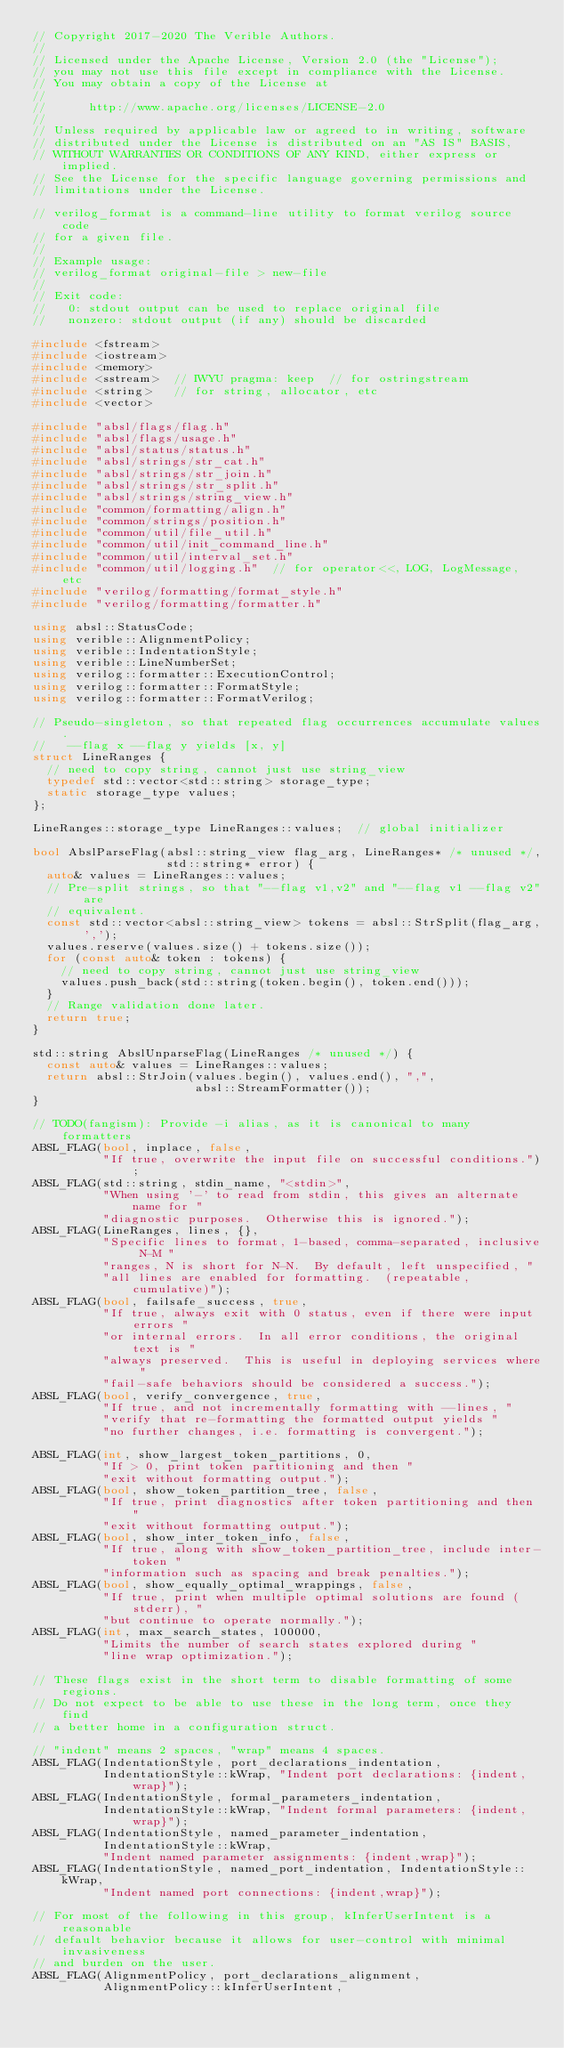Convert code to text. <code><loc_0><loc_0><loc_500><loc_500><_C++_>// Copyright 2017-2020 The Verible Authors.
//
// Licensed under the Apache License, Version 2.0 (the "License");
// you may not use this file except in compliance with the License.
// You may obtain a copy of the License at
//
//      http://www.apache.org/licenses/LICENSE-2.0
//
// Unless required by applicable law or agreed to in writing, software
// distributed under the License is distributed on an "AS IS" BASIS,
// WITHOUT WARRANTIES OR CONDITIONS OF ANY KIND, either express or implied.
// See the License for the specific language governing permissions and
// limitations under the License.

// verilog_format is a command-line utility to format verilog source code
// for a given file.
//
// Example usage:
// verilog_format original-file > new-file
//
// Exit code:
//   0: stdout output can be used to replace original file
//   nonzero: stdout output (if any) should be discarded

#include <fstream>
#include <iostream>
#include <memory>
#include <sstream>  // IWYU pragma: keep  // for ostringstream
#include <string>   // for string, allocator, etc
#include <vector>

#include "absl/flags/flag.h"
#include "absl/flags/usage.h"
#include "absl/status/status.h"
#include "absl/strings/str_cat.h"
#include "absl/strings/str_join.h"
#include "absl/strings/str_split.h"
#include "absl/strings/string_view.h"
#include "common/formatting/align.h"
#include "common/strings/position.h"
#include "common/util/file_util.h"
#include "common/util/init_command_line.h"
#include "common/util/interval_set.h"
#include "common/util/logging.h"  // for operator<<, LOG, LogMessage, etc
#include "verilog/formatting/format_style.h"
#include "verilog/formatting/formatter.h"

using absl::StatusCode;
using verible::AlignmentPolicy;
using verible::IndentationStyle;
using verible::LineNumberSet;
using verilog::formatter::ExecutionControl;
using verilog::formatter::FormatStyle;
using verilog::formatter::FormatVerilog;

// Pseudo-singleton, so that repeated flag occurrences accumulate values.
//   --flag x --flag y yields [x, y]
struct LineRanges {
  // need to copy string, cannot just use string_view
  typedef std::vector<std::string> storage_type;
  static storage_type values;
};

LineRanges::storage_type LineRanges::values;  // global initializer

bool AbslParseFlag(absl::string_view flag_arg, LineRanges* /* unused */,
                   std::string* error) {
  auto& values = LineRanges::values;
  // Pre-split strings, so that "--flag v1,v2" and "--flag v1 --flag v2" are
  // equivalent.
  const std::vector<absl::string_view> tokens = absl::StrSplit(flag_arg, ',');
  values.reserve(values.size() + tokens.size());
  for (const auto& token : tokens) {
    // need to copy string, cannot just use string_view
    values.push_back(std::string(token.begin(), token.end()));
  }
  // Range validation done later.
  return true;
}

std::string AbslUnparseFlag(LineRanges /* unused */) {
  const auto& values = LineRanges::values;
  return absl::StrJoin(values.begin(), values.end(), ",",
                       absl::StreamFormatter());
}

// TODO(fangism): Provide -i alias, as it is canonical to many formatters
ABSL_FLAG(bool, inplace, false,
          "If true, overwrite the input file on successful conditions.");
ABSL_FLAG(std::string, stdin_name, "<stdin>",
          "When using '-' to read from stdin, this gives an alternate name for "
          "diagnostic purposes.  Otherwise this is ignored.");
ABSL_FLAG(LineRanges, lines, {},
          "Specific lines to format, 1-based, comma-separated, inclusive N-M "
          "ranges, N is short for N-N.  By default, left unspecified, "
          "all lines are enabled for formatting.  (repeatable, cumulative)");
ABSL_FLAG(bool, failsafe_success, true,
          "If true, always exit with 0 status, even if there were input errors "
          "or internal errors.  In all error conditions, the original text is "
          "always preserved.  This is useful in deploying services where "
          "fail-safe behaviors should be considered a success.");
ABSL_FLAG(bool, verify_convergence, true,
          "If true, and not incrementally formatting with --lines, "
          "verify that re-formatting the formatted output yields "
          "no further changes, i.e. formatting is convergent.");

ABSL_FLAG(int, show_largest_token_partitions, 0,
          "If > 0, print token partitioning and then "
          "exit without formatting output.");
ABSL_FLAG(bool, show_token_partition_tree, false,
          "If true, print diagnostics after token partitioning and then "
          "exit without formatting output.");
ABSL_FLAG(bool, show_inter_token_info, false,
          "If true, along with show_token_partition_tree, include inter-token "
          "information such as spacing and break penalties.");
ABSL_FLAG(bool, show_equally_optimal_wrappings, false,
          "If true, print when multiple optimal solutions are found (stderr), "
          "but continue to operate normally.");
ABSL_FLAG(int, max_search_states, 100000,
          "Limits the number of search states explored during "
          "line wrap optimization.");

// These flags exist in the short term to disable formatting of some regions.
// Do not expect to be able to use these in the long term, once they find
// a better home in a configuration struct.

// "indent" means 2 spaces, "wrap" means 4 spaces.
ABSL_FLAG(IndentationStyle, port_declarations_indentation,
          IndentationStyle::kWrap, "Indent port declarations: {indent,wrap}");
ABSL_FLAG(IndentationStyle, formal_parameters_indentation,
          IndentationStyle::kWrap, "Indent formal parameters: {indent,wrap}");
ABSL_FLAG(IndentationStyle, named_parameter_indentation,
          IndentationStyle::kWrap,
          "Indent named parameter assignments: {indent,wrap}");
ABSL_FLAG(IndentationStyle, named_port_indentation, IndentationStyle::kWrap,
          "Indent named port connections: {indent,wrap}");

// For most of the following in this group, kInferUserIntent is a reasonable
// default behavior because it allows for user-control with minimal invasiveness
// and burden on the user.
ABSL_FLAG(AlignmentPolicy, port_declarations_alignment,
          AlignmentPolicy::kInferUserIntent,</code> 